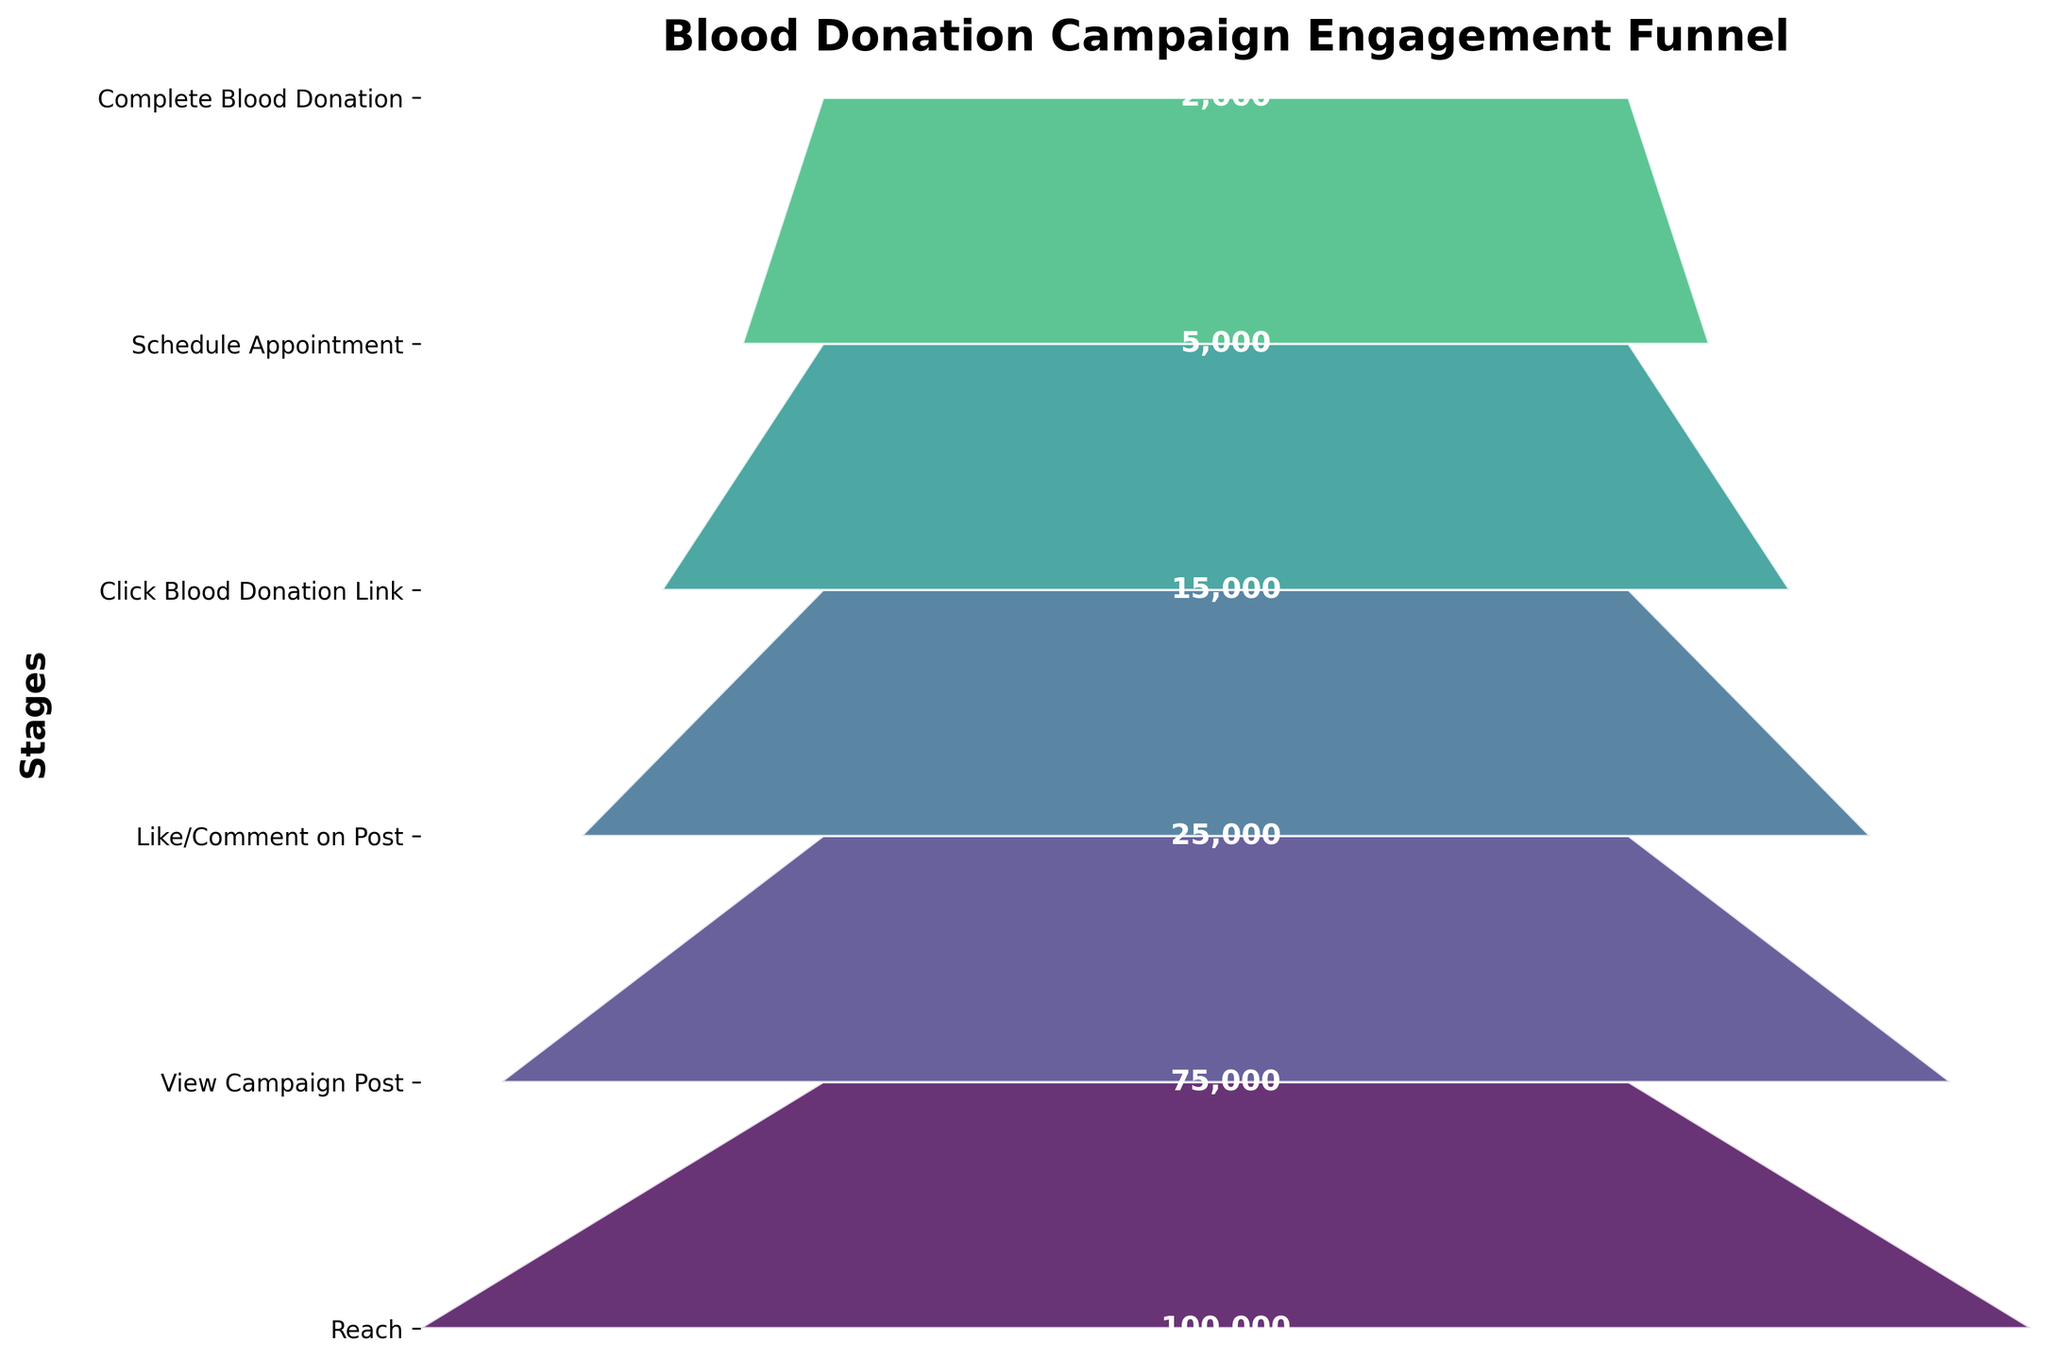What is the title of the chart? The title is the text that appears at the top of the chart and describes the main topic or purpose of the chart. The title in this case helps to understand what the funnel chart is about.
Answer: Blood Donation Campaign Engagement Funnel How many stages are shown in the funnel chart? By counting each labeled stage on the y-axis, you can determine the number of stages represented in the funnel.
Answer: Six Which stage has the highest number of followers? Identify the stage with the largest number displayed in the funnel segments. The topmost segment in the funnel chart indicates the number of followers at the beginning stage.
Answer: Reach What is the difference in the number of followers between the stages "View Campaign Post" and "Schedule Appointment"? Subtract the number of followers at the "Schedule Appointment" stage from those at the "View Campaign Post" stage to find the difference.
Answer: 75000 - 5000 = 70000 What percentage of followers who "Click Blood Donation Link" actually "Complete Blood Donation"? Divide the number of followers who "Complete Blood Donation" by those who "Click Blood Donation Link" and multiply by 100 to get the percentage.
Answer: (2000 / 15000) * 100 = 13.33% How many more followers viewed the campaign post than those who clicked the blood donation link? Subtract the number of followers who clicked the blood donation link from those who viewed the campaign post to find the difference.
Answer: 75000 - 15000 = 60000 Which stage sees the greatest drop in the number of followers? Identify the two consecutive stages with the largest difference in the number of followers by calculating the difference between each pair of consecutive stages.
Answer: Schedule Appointment to Complete Blood Donation What proportion of followers who "Like/Comment on Post" end up "Scheduling an Appointment"? Divide the number of followers who scheduled an appointment by those who liked or commented on the post and multiply by 100 to get the proportion.
Answer: (5000 / 25000) * 100 = 20% How does the number of followers who "Schedule Appointment" compare to those who "Complete Blood Donation"? Compare the numbers directly from the funnel chart to see how much larger one group is compared to the other.
Answer: 5000 vs 2000; Schedule Appointment is more By what factor does the number of followers decrease from "Reach" to "Complete Blood Donation"? Divide the number of followers at the "Reach" stage by the number at the "Complete Blood Donation" stage to find the factor.
Answer: 100000 / 2000 = 50 